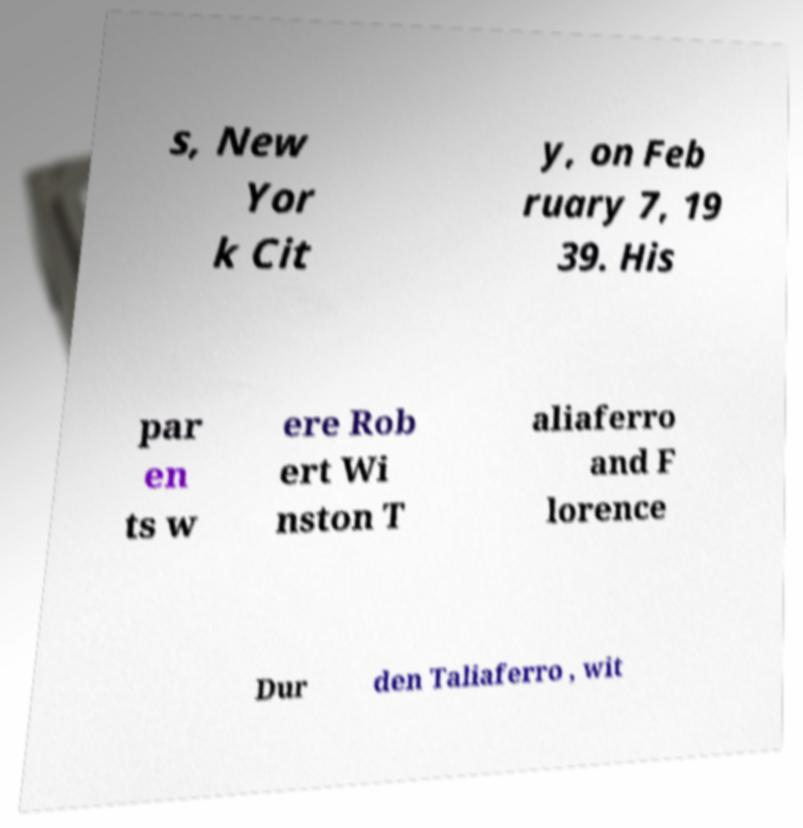Could you assist in decoding the text presented in this image and type it out clearly? s, New Yor k Cit y, on Feb ruary 7, 19 39. His par en ts w ere Rob ert Wi nston T aliaferro and F lorence Dur den Taliaferro , wit 